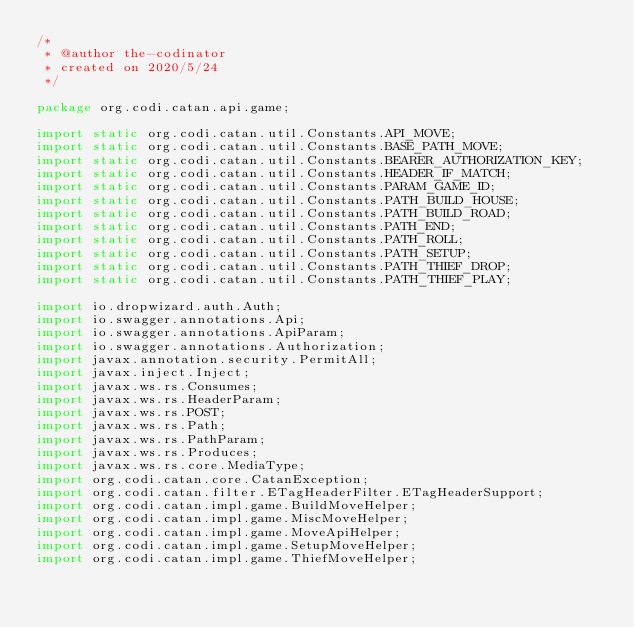Convert code to text. <code><loc_0><loc_0><loc_500><loc_500><_Java_>/*
 * @author the-codinator
 * created on 2020/5/24
 */

package org.codi.catan.api.game;

import static org.codi.catan.util.Constants.API_MOVE;
import static org.codi.catan.util.Constants.BASE_PATH_MOVE;
import static org.codi.catan.util.Constants.BEARER_AUTHORIZATION_KEY;
import static org.codi.catan.util.Constants.HEADER_IF_MATCH;
import static org.codi.catan.util.Constants.PARAM_GAME_ID;
import static org.codi.catan.util.Constants.PATH_BUILD_HOUSE;
import static org.codi.catan.util.Constants.PATH_BUILD_ROAD;
import static org.codi.catan.util.Constants.PATH_END;
import static org.codi.catan.util.Constants.PATH_ROLL;
import static org.codi.catan.util.Constants.PATH_SETUP;
import static org.codi.catan.util.Constants.PATH_THIEF_DROP;
import static org.codi.catan.util.Constants.PATH_THIEF_PLAY;

import io.dropwizard.auth.Auth;
import io.swagger.annotations.Api;
import io.swagger.annotations.ApiParam;
import io.swagger.annotations.Authorization;
import javax.annotation.security.PermitAll;
import javax.inject.Inject;
import javax.ws.rs.Consumes;
import javax.ws.rs.HeaderParam;
import javax.ws.rs.POST;
import javax.ws.rs.Path;
import javax.ws.rs.PathParam;
import javax.ws.rs.Produces;
import javax.ws.rs.core.MediaType;
import org.codi.catan.core.CatanException;
import org.codi.catan.filter.ETagHeaderFilter.ETagHeaderSupport;
import org.codi.catan.impl.game.BuildMoveHelper;
import org.codi.catan.impl.game.MiscMoveHelper;
import org.codi.catan.impl.game.MoveApiHelper;
import org.codi.catan.impl.game.SetupMoveHelper;
import org.codi.catan.impl.game.ThiefMoveHelper;</code> 